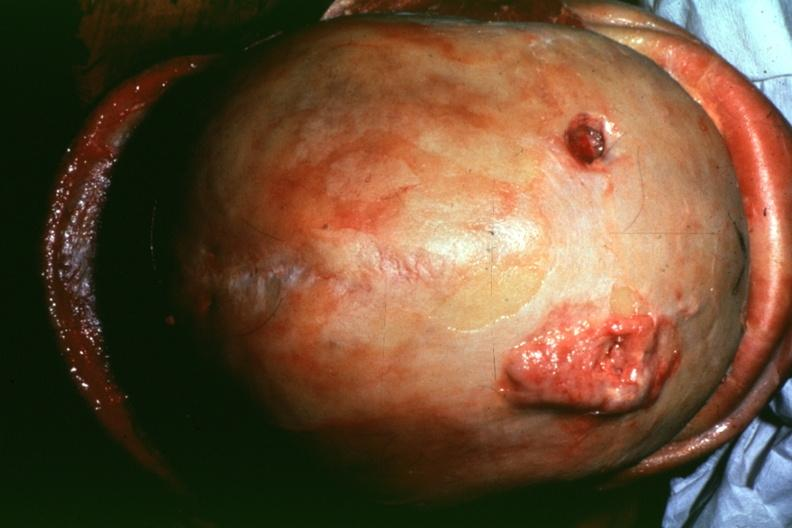s metastatic lung carcinoma present?
Answer the question using a single word or phrase. Yes 